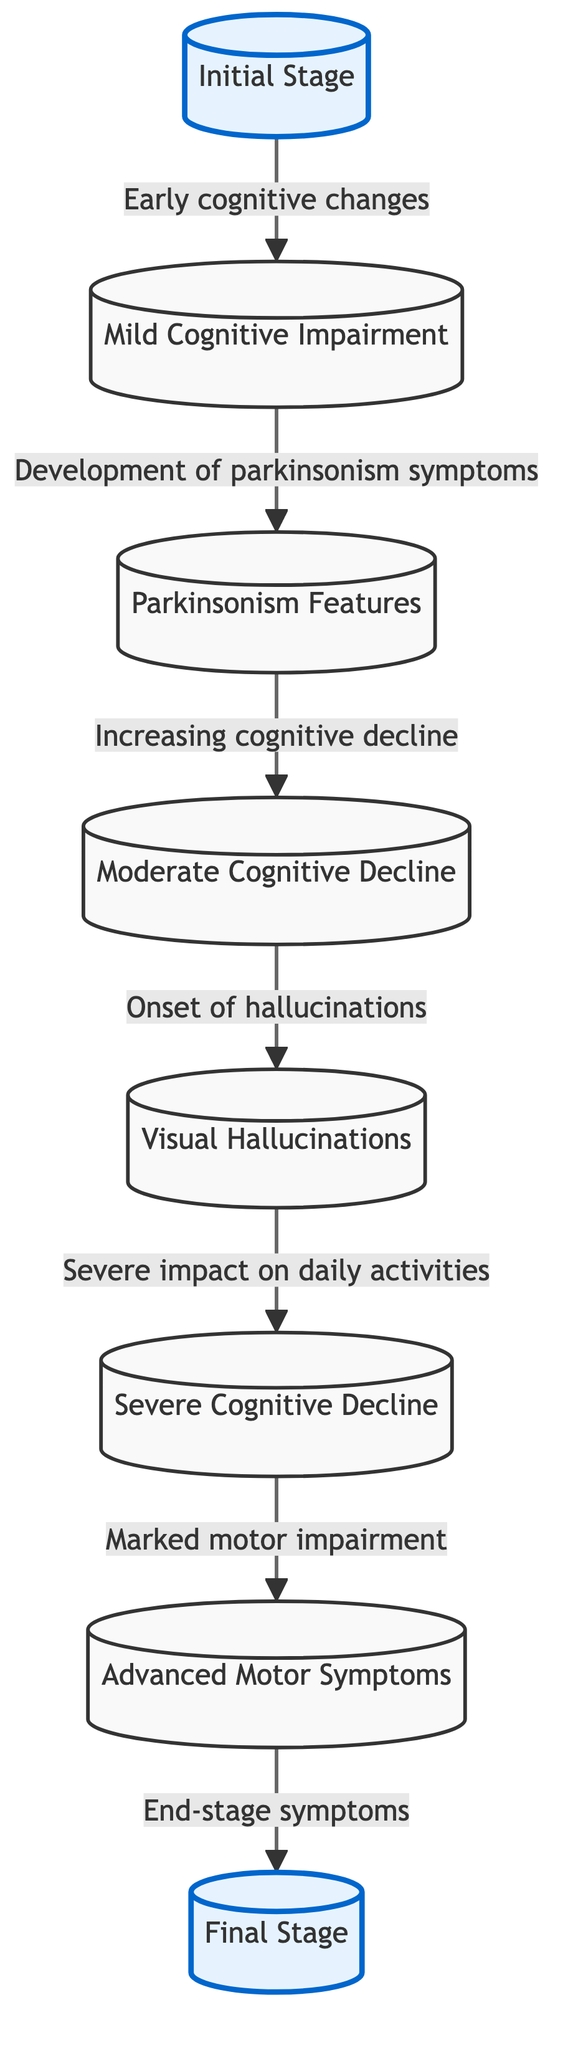What is the starting point of the progression in the diagram? The first node in the diagram represents the "Initial Stage," indicating it is the starting point of the progression of Lewy Body Dementia.
Answer: Initial Stage How many stages are shown in this diagram? The diagram contains a total of eight nodes, which represent distinct stages in the progression of Lewy Body Dementia, giving a clear view of the disease's advancement.
Answer: Eight What symptom is associated with the transition from "Moderate Cognitive Decline"? The transition mentioned indicates that from "Moderate Cognitive Decline," the onset of "Visual Hallucinations" occurs, marking an important symptom in the progression.
Answer: Visual Hallucinations Which stage comes directly after "Severe Cognitive Decline"? According to the flow of the diagram, the stage that follows "Severe Cognitive Decline" is "Advanced Motor Symptoms," demonstrating the sequential nature of these stages.
Answer: Advanced Motor Symptoms What change is noted in the relationship between "Mild Cognitive Impairment" and "Parkinsonism Features"? The arrow connecting "Mild Cognitive Impairment" to "Parkinsonism Features" signifies that as mild cognitive impairment emerges, parkinsonism symptoms begin to develop, indicating a simultaneous relationship between cognitive and motor changes.
Answer: Development of parkinsonism symptoms What is the final stage in the progression of Lewy Body Dementia that is depicted? The last node in the flowchart illustrates the "Final Stage," capturing the end point of the disease's progression and the severity of symptoms at that stage.
Answer: Final Stage What is the effect of "Visual Hallucinations" on cognitive decline, according to the diagram? The diagram specifies that "Visual Hallucinations" correlate with "Severe Cognitive Decline," showing how hallucinations intensify the cognitive challenges faced by patients.
Answer: Severe impact on daily activities In how many transitions does "Moderate Cognitive Decline" occur before reaching the final stage? "Moderate Cognitive Decline" leads through two transitions, first to "Visual Hallucinations" and then to "Severe Cognitive Decline," before the final stage is reached.
Answer: Two transitions What is the common theme across the stages shown in this diagram? The shared theme among all stages is the escalation of cognitive and motor symptoms, emphasizing the progressive nature of Lewy Body Dementia from initial to final stage.
Answer: Escalation of symptoms 